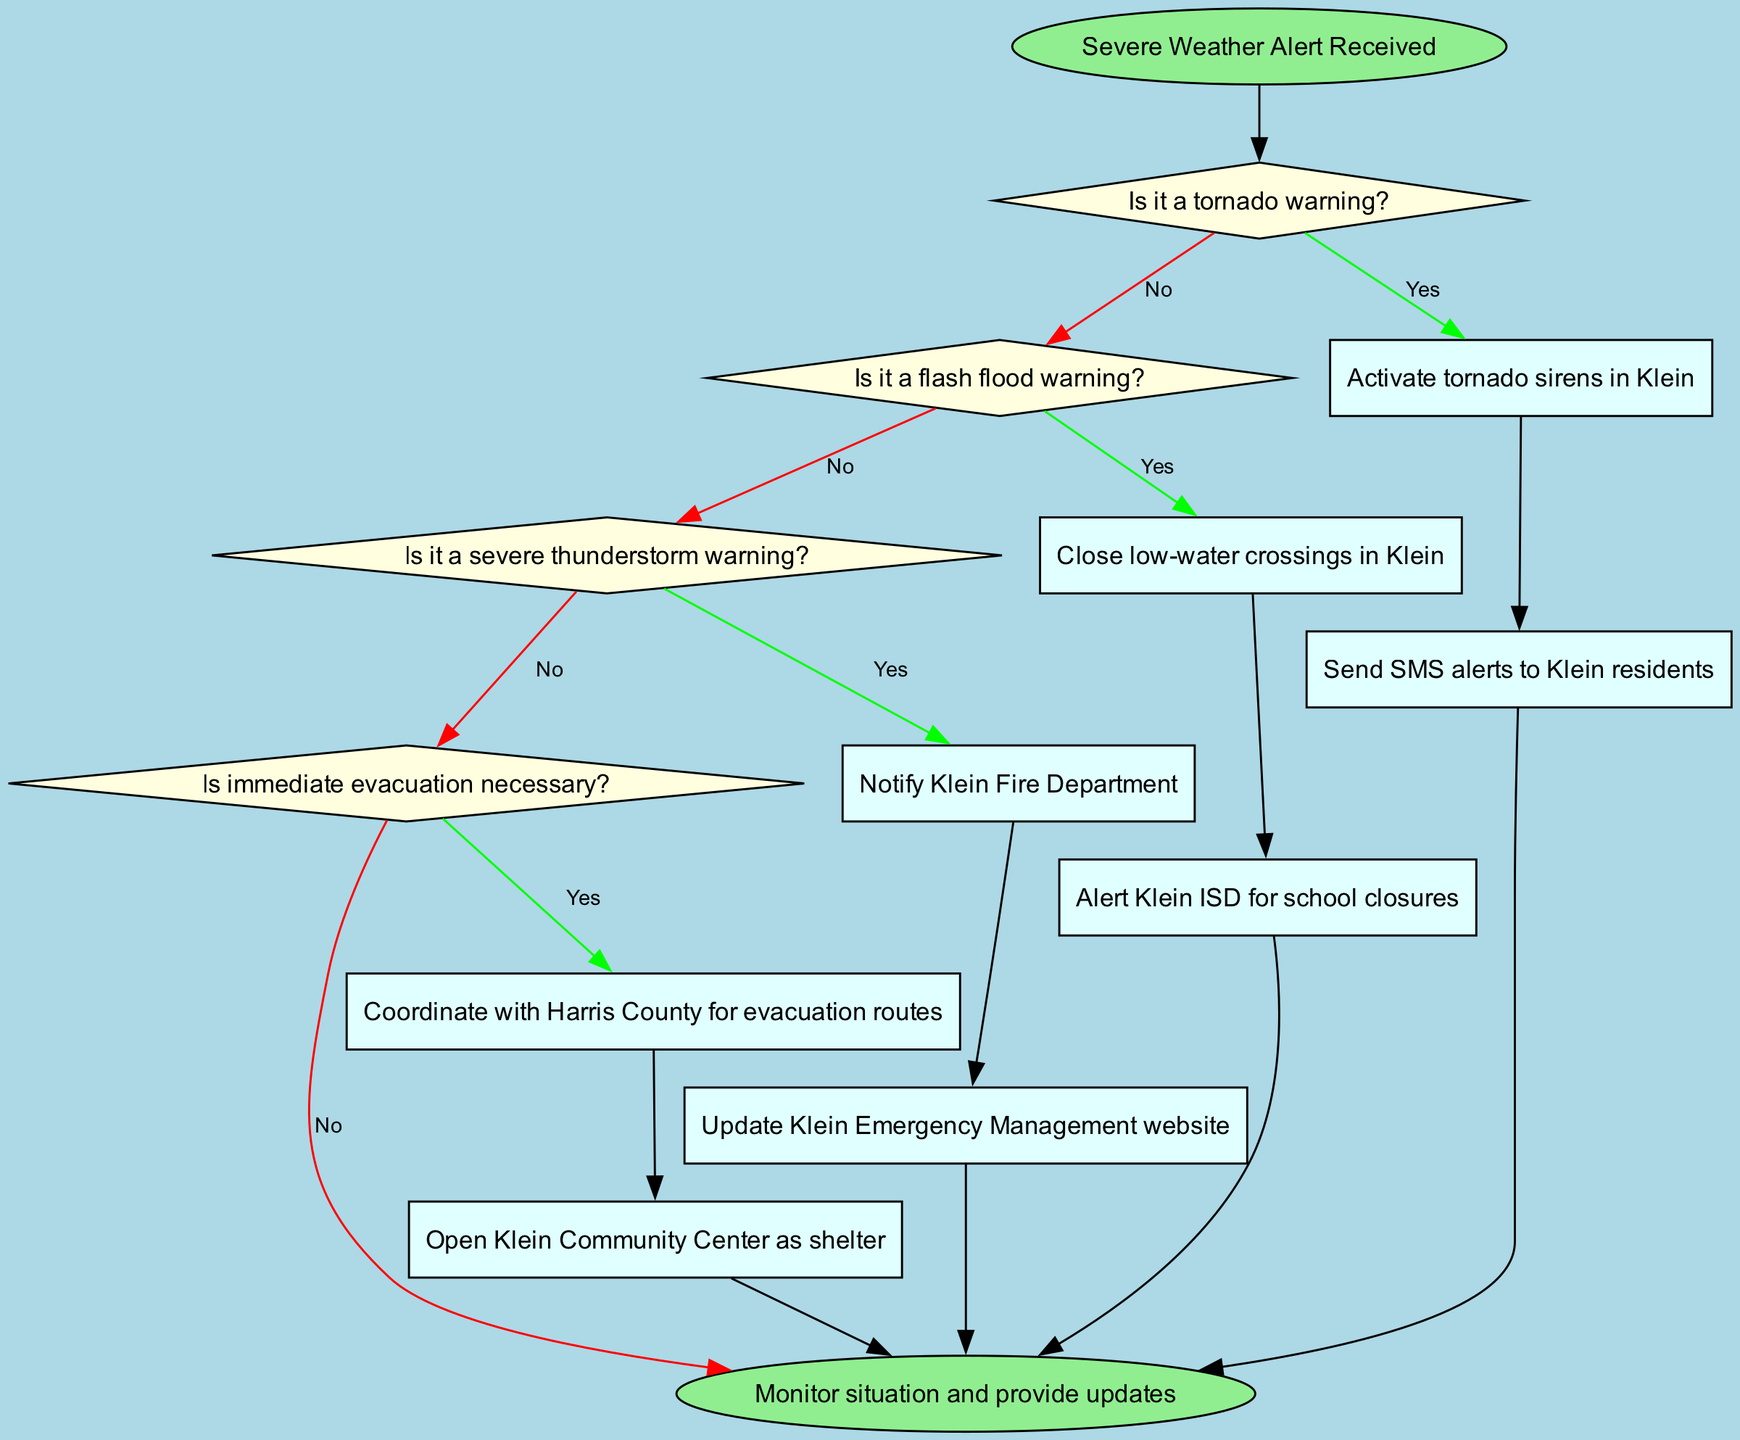What is the starting point of the flowchart? The flowchart starts with the node labeled "Severe Weather Alert Received", which represents the initial step in the emergency response process.
Answer: Severe Weather Alert Received How many decision nodes are in the flowchart? There are four decision nodes, labeled as decision1 through decision4, which indicate points where a choice must be made based on specific weather alerts.
Answer: 4 What action is taken if a tornado warning is received? If a tornado warning is received ('Yes' branch from decision1), the flowchart specifies the action "Activate tornado sirens in Klein".
Answer: Activate tornado sirens in Klein Which process follows the decision about a flash flood warning? If there is no tornado warning (the 'No' branch from decision1), the next decision is about flash flood warnings, leading to process3 "Close low-water crossings in Klein" if the flash flood warning is confirmed ('Yes' branch from decision2).
Answer: Close low-water crossings in Klein What happens if immediate evacuation is necessary? If the response team determines that immediate evacuation is required ('Yes' branch from decision4), the process involves "Coordinate with Harris County for evacuation routes".
Answer: Coordinate with Harris County for evacuation routes What is the final step in the flowchart? The last step in the flowchart is labeled "Monitor situation and provide updates", which indicates the ongoing responsibility of keeping an eye on the situation after all necessary actions have been taken.
Answer: Monitor situation and provide updates What is the relationship between process2 and the end node? Process2 ("Send SMS alerts to Klein residents") directly connects to the end node in the flowchart, indicating that after sending alerts, the process concludes.
Answer: End Which department is notified during a severe thunderstorm warning? The flowchart specifies that the "Klein Fire Department" is notified as the process for the severe thunderstorm warning ('Yes' branch from decision3).
Answer: Klein Fire Department 